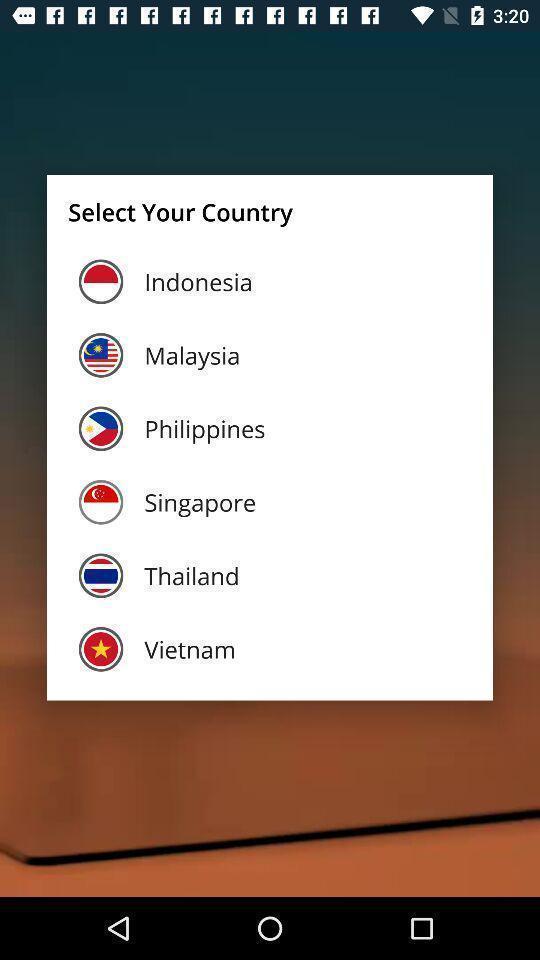Tell me about the visual elements in this screen capture. Pop-up shows to select a country. 